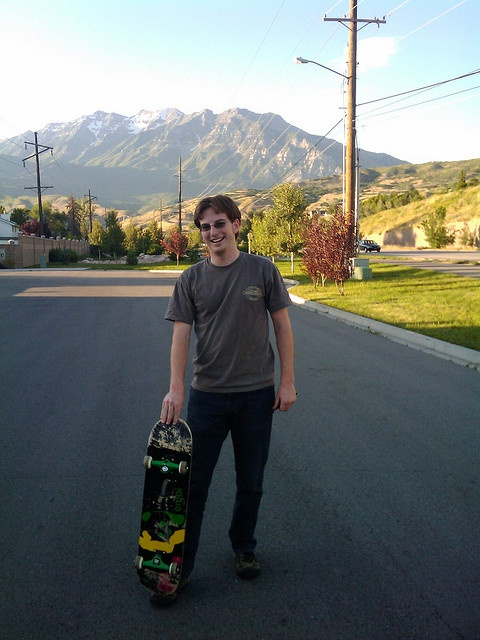Describe the objects in this image and their specific colors. I can see people in white, black, and gray tones, skateboard in ivory, black, gray, olive, and darkgreen tones, and car in white, black, gray, and darkgray tones in this image. 